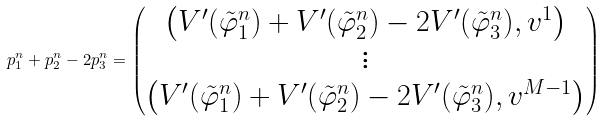Convert formula to latex. <formula><loc_0><loc_0><loc_500><loc_500>p ^ { n } _ { 1 } + p ^ { n } _ { 2 } - 2 p ^ { n } _ { 3 } = \begin{pmatrix} \left ( V ^ { \prime } ( \tilde { \varphi } ^ { n } _ { 1 } ) + V ^ { \prime } ( \tilde { \varphi } ^ { n } _ { 2 } ) - 2 V ^ { \prime } ( \tilde { \varphi } ^ { n } _ { 3 } ) , v ^ { 1 } \right ) \\ \vdots \\ \left ( V ^ { \prime } ( \tilde { \varphi } ^ { n } _ { 1 } ) + V ^ { \prime } ( \tilde { \varphi } ^ { n } _ { 2 } ) - 2 V ^ { \prime } ( \tilde { \varphi } ^ { n } _ { 3 } ) , v ^ { M - 1 } \right ) \end{pmatrix}</formula> 